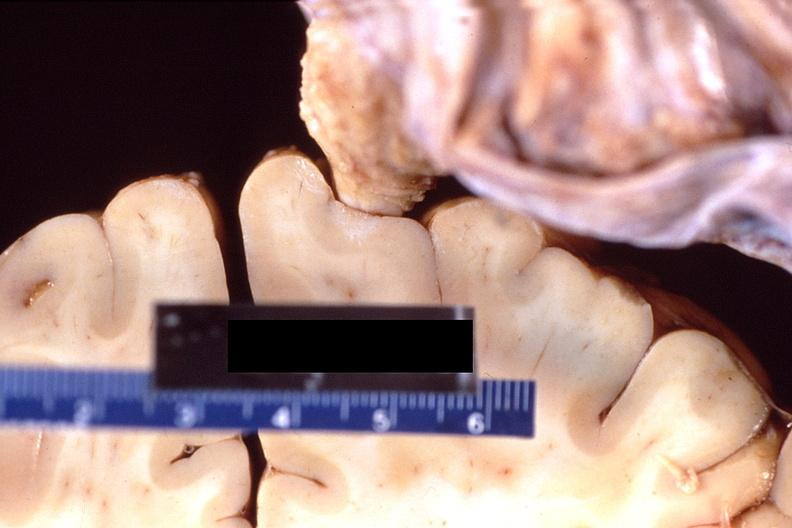s nervous present?
Answer the question using a single word or phrase. Yes 